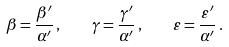<formula> <loc_0><loc_0><loc_500><loc_500>\beta = \frac { \beta ^ { \prime } } { \alpha ^ { \prime } } \, , \quad \gamma = \frac { \gamma ^ { \prime } } { \alpha ^ { \prime } } \, , \quad \varepsilon = \frac { \varepsilon ^ { \prime } } { \alpha ^ { \prime } } \, .</formula> 